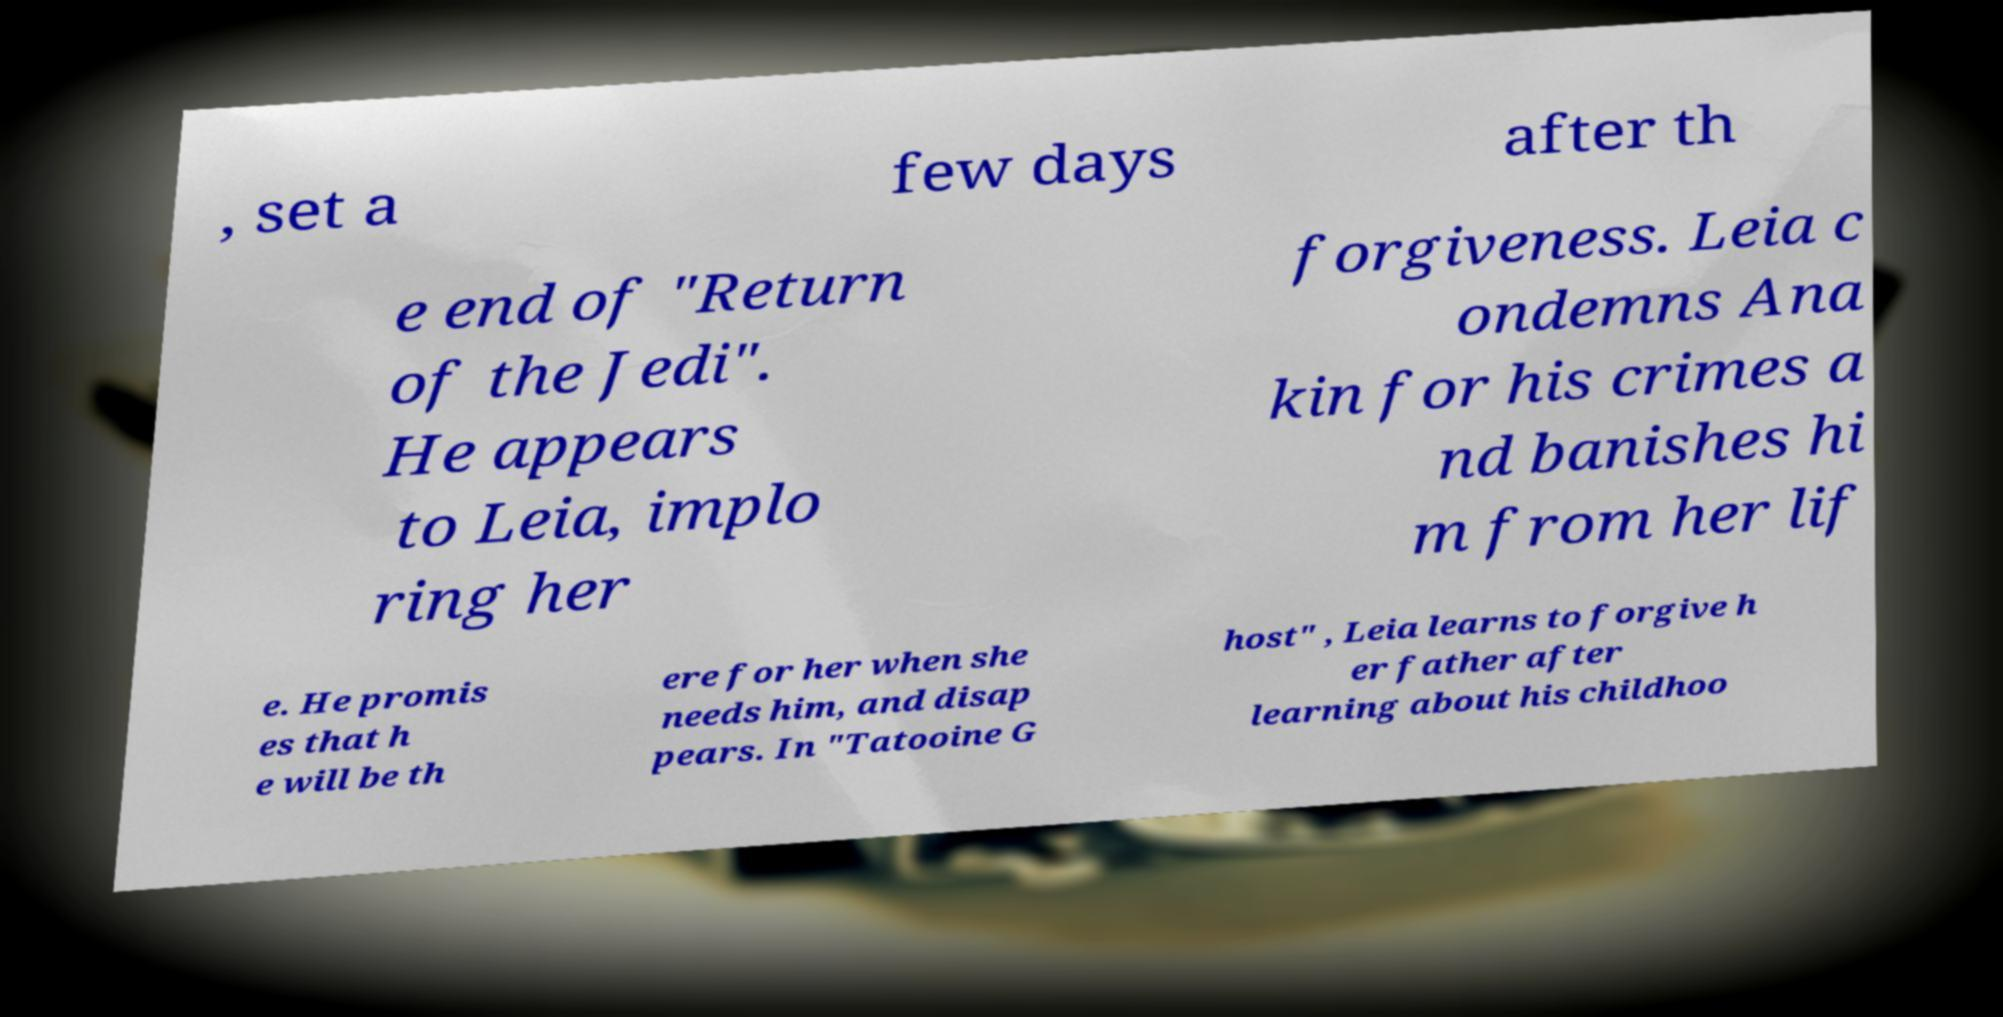I need the written content from this picture converted into text. Can you do that? , set a few days after th e end of "Return of the Jedi". He appears to Leia, implo ring her forgiveness. Leia c ondemns Ana kin for his crimes a nd banishes hi m from her lif e. He promis es that h e will be th ere for her when she needs him, and disap pears. In "Tatooine G host" , Leia learns to forgive h er father after learning about his childhoo 